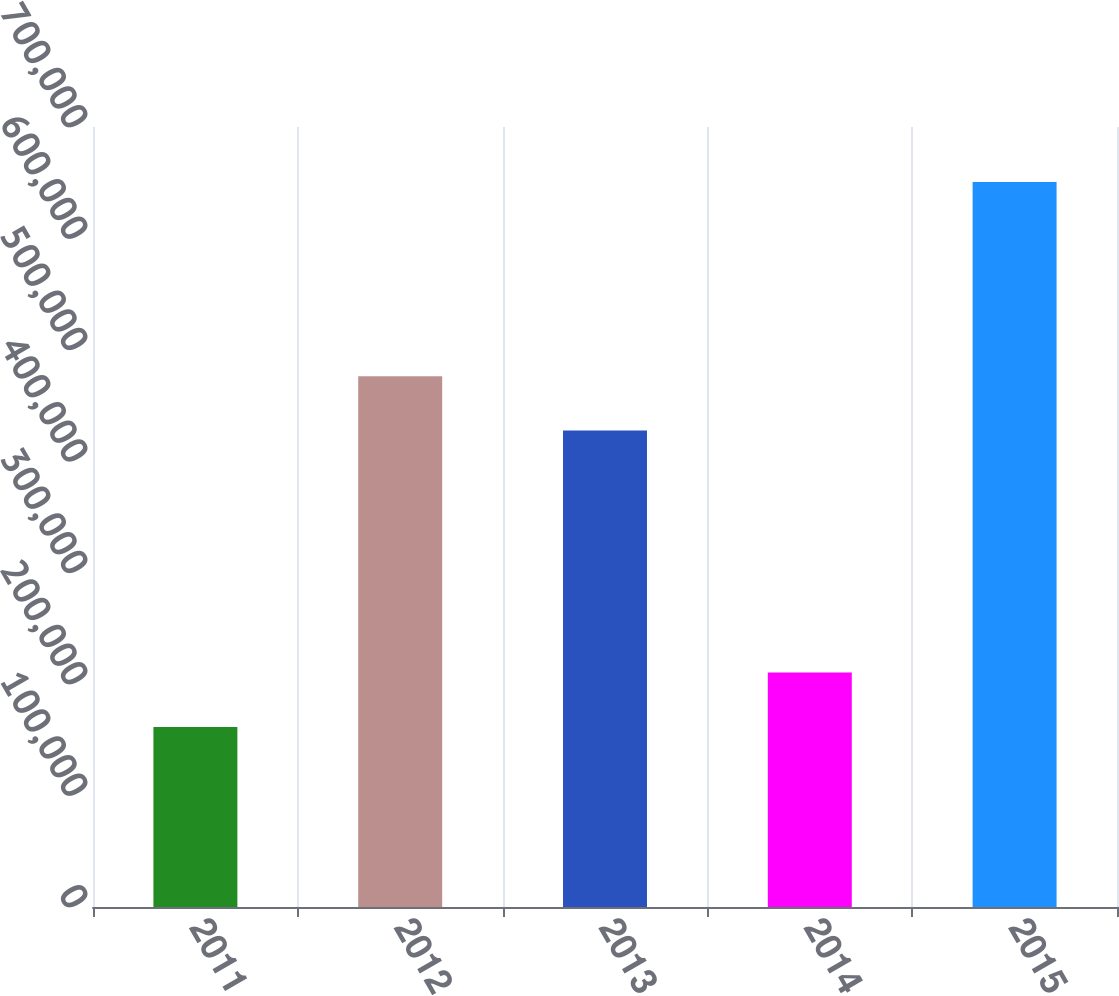<chart> <loc_0><loc_0><loc_500><loc_500><bar_chart><fcel>2011<fcel>2012<fcel>2013<fcel>2014<fcel>2015<nl><fcel>161622<fcel>476423<fcel>427529<fcel>210516<fcel>650558<nl></chart> 